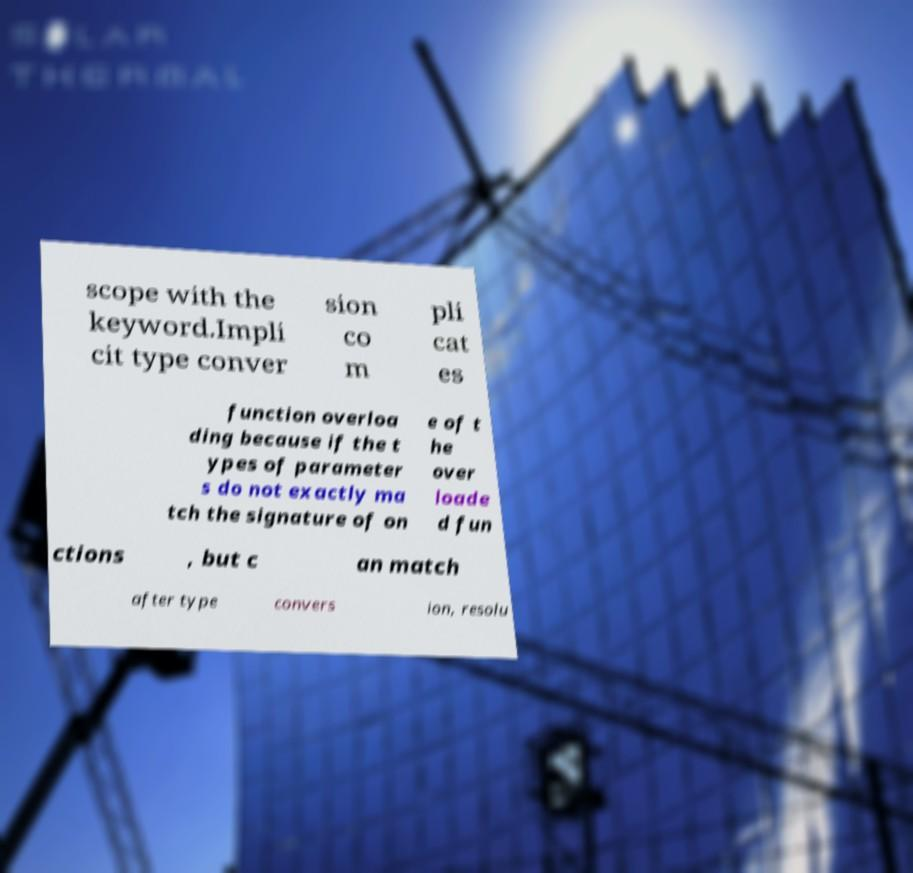Can you accurately transcribe the text from the provided image for me? scope with the keyword.Impli cit type conver sion co m pli cat es function overloa ding because if the t ypes of parameter s do not exactly ma tch the signature of on e of t he over loade d fun ctions , but c an match after type convers ion, resolu 